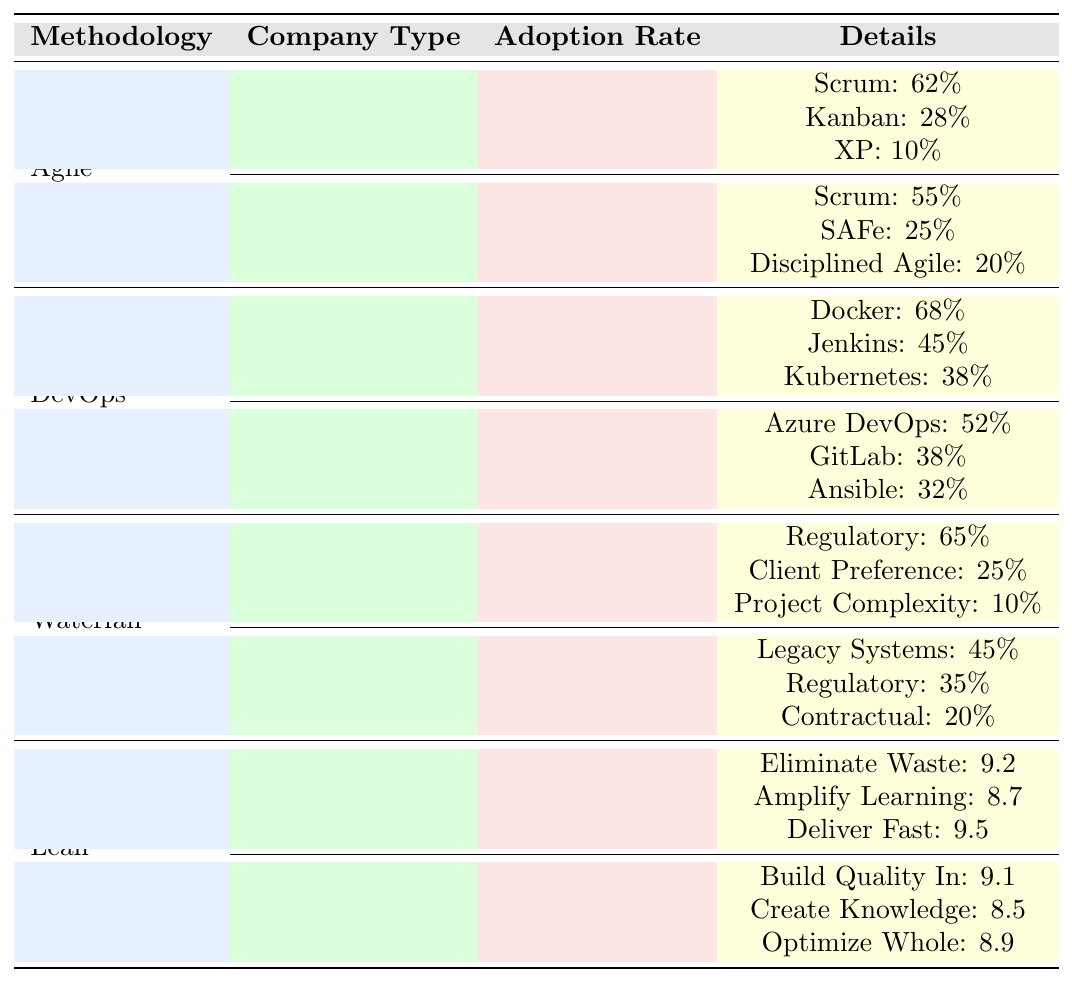What is the adoption rate of Agile in startups? The adoption rate for Agile in startups is directly given in the table, which states that it is 78%.
Answer: 78% Which popular Agile framework is most used by enterprise companies? By examining the details under the Enterprise category for Agile, Scrum is listed, which has a usage rate of 55%, making it the most used framework in this group.
Answer: Scrum What is the difference in adoption rates of DevOps between startups and enterprise companies? The adoption rate for DevOps in startups is 72%, while for enterprise companies it is 58%. The difference is calculated as 72% - 58% = 14%.
Answer: 14% Which methodology has the highest adoption rate among startups? The table indicates that Agile has the highest adoption rate for startups at 78%, higher than the other methodologies listed for startups.
Answer: Agile What percentage of startups use Waterfall methodology for regulatory requirements? The table shows that 65% of startups using the Waterfall methodology cite regulatory requirements as a reason for its use.
Answer: 65% Does the adoption rate of Lean methodology differ significantly between startups and enterprises? Startups have a Lean adoption rate of 45% while enterprises have 38%, showing a difference of 7%. Therefore, there is a notable difference, but it is not overly significant.
Answer: Yes What is the average usage rate of popular DevOps tools in startups? The total usage for DevOps tools in startups can be calculated as 68 + 45 + 38 = 151. Since there are 3 tools, the average usage is 151 / 3 = 50.33 (approx).
Answer: 50.33 Which methodology has the highest percentage of clients preferring its use in the Waterfall category for enterprise companies? For enterprise companies using Waterfall methodology, the highest percentage of client preference is 45%, associated with legacy systems.
Answer: 45% What is the least adopted methodology in startups? The table indicates that Waterfall is the least adopted methodology in startups with a percentage of only 8%.
Answer: Waterfall Are there any frameworks listed under Lean methodology in enterprise companies? The table specifies that there are no frameworks under Lean methodology for enterprise companies, only key principles are mentioned. Hence, the answer is no.
Answer: No 